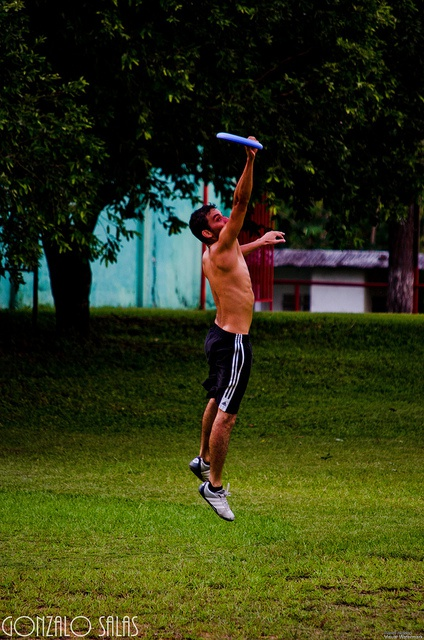Describe the objects in this image and their specific colors. I can see people in black, maroon, and brown tones and frisbee in black, lightblue, blue, and darkblue tones in this image. 